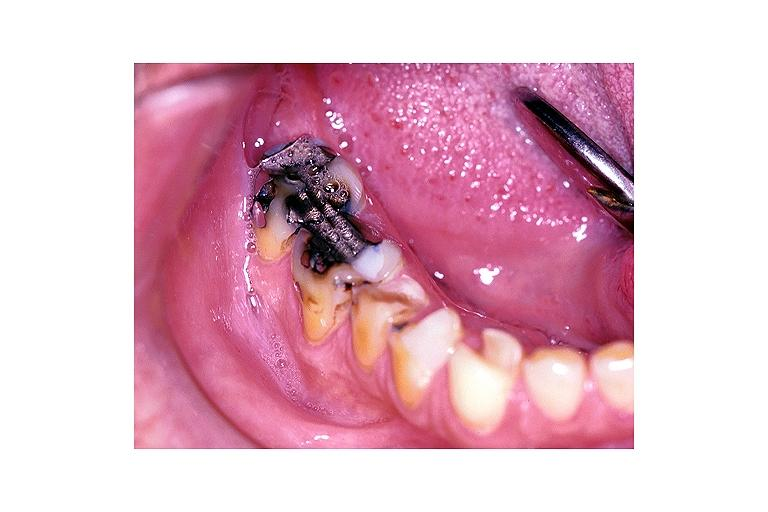s palmar crease normal present?
Answer the question using a single word or phrase. No 